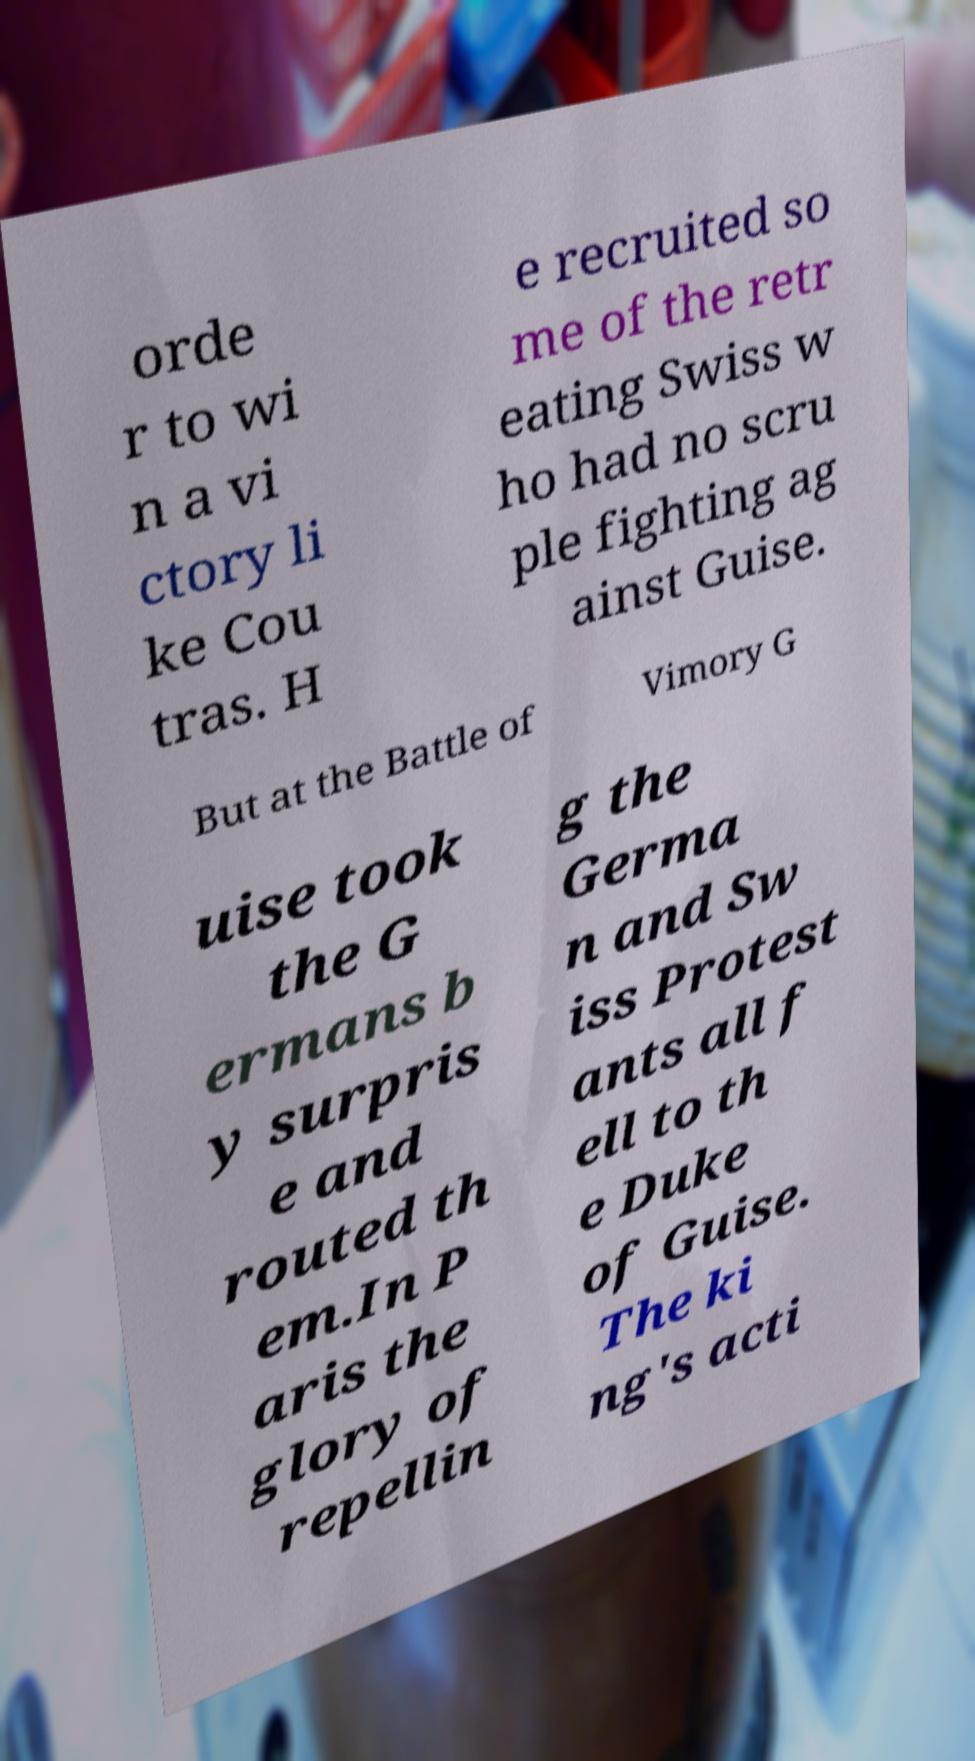Please read and relay the text visible in this image. What does it say? orde r to wi n a vi ctory li ke Cou tras. H e recruited so me of the retr eating Swiss w ho had no scru ple fighting ag ainst Guise. But at the Battle of Vimory G uise took the G ermans b y surpris e and routed th em.In P aris the glory of repellin g the Germa n and Sw iss Protest ants all f ell to th e Duke of Guise. The ki ng's acti 